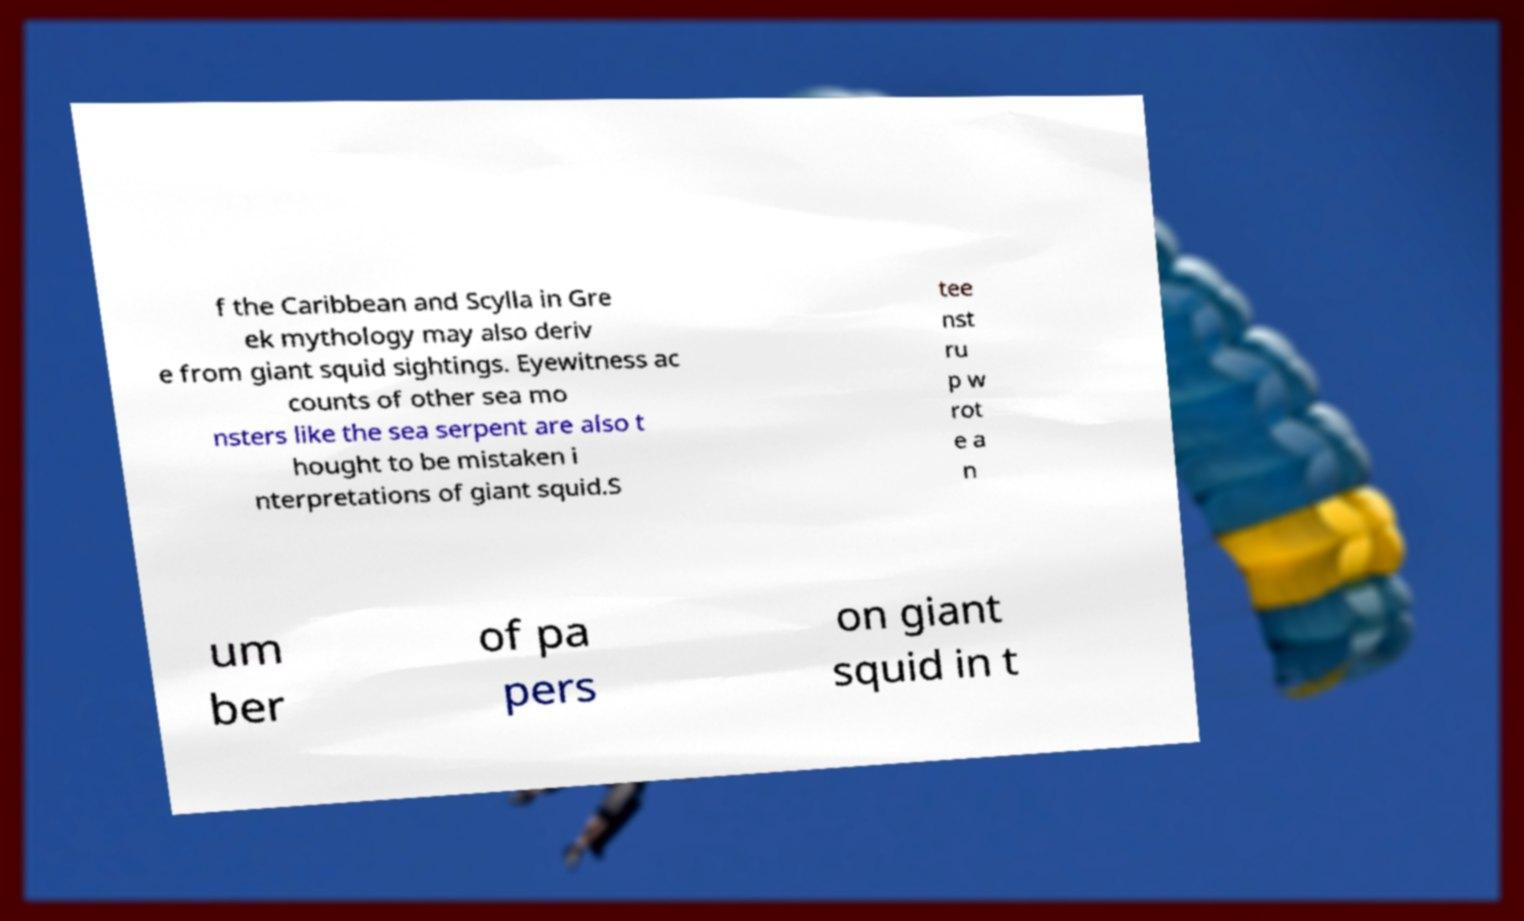Could you assist in decoding the text presented in this image and type it out clearly? f the Caribbean and Scylla in Gre ek mythology may also deriv e from giant squid sightings. Eyewitness ac counts of other sea mo nsters like the sea serpent are also t hought to be mistaken i nterpretations of giant squid.S tee nst ru p w rot e a n um ber of pa pers on giant squid in t 